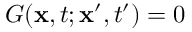Convert formula to latex. <formula><loc_0><loc_0><loc_500><loc_500>G ( x , t ; x ^ { \prime } , t ^ { \prime } ) = 0</formula> 